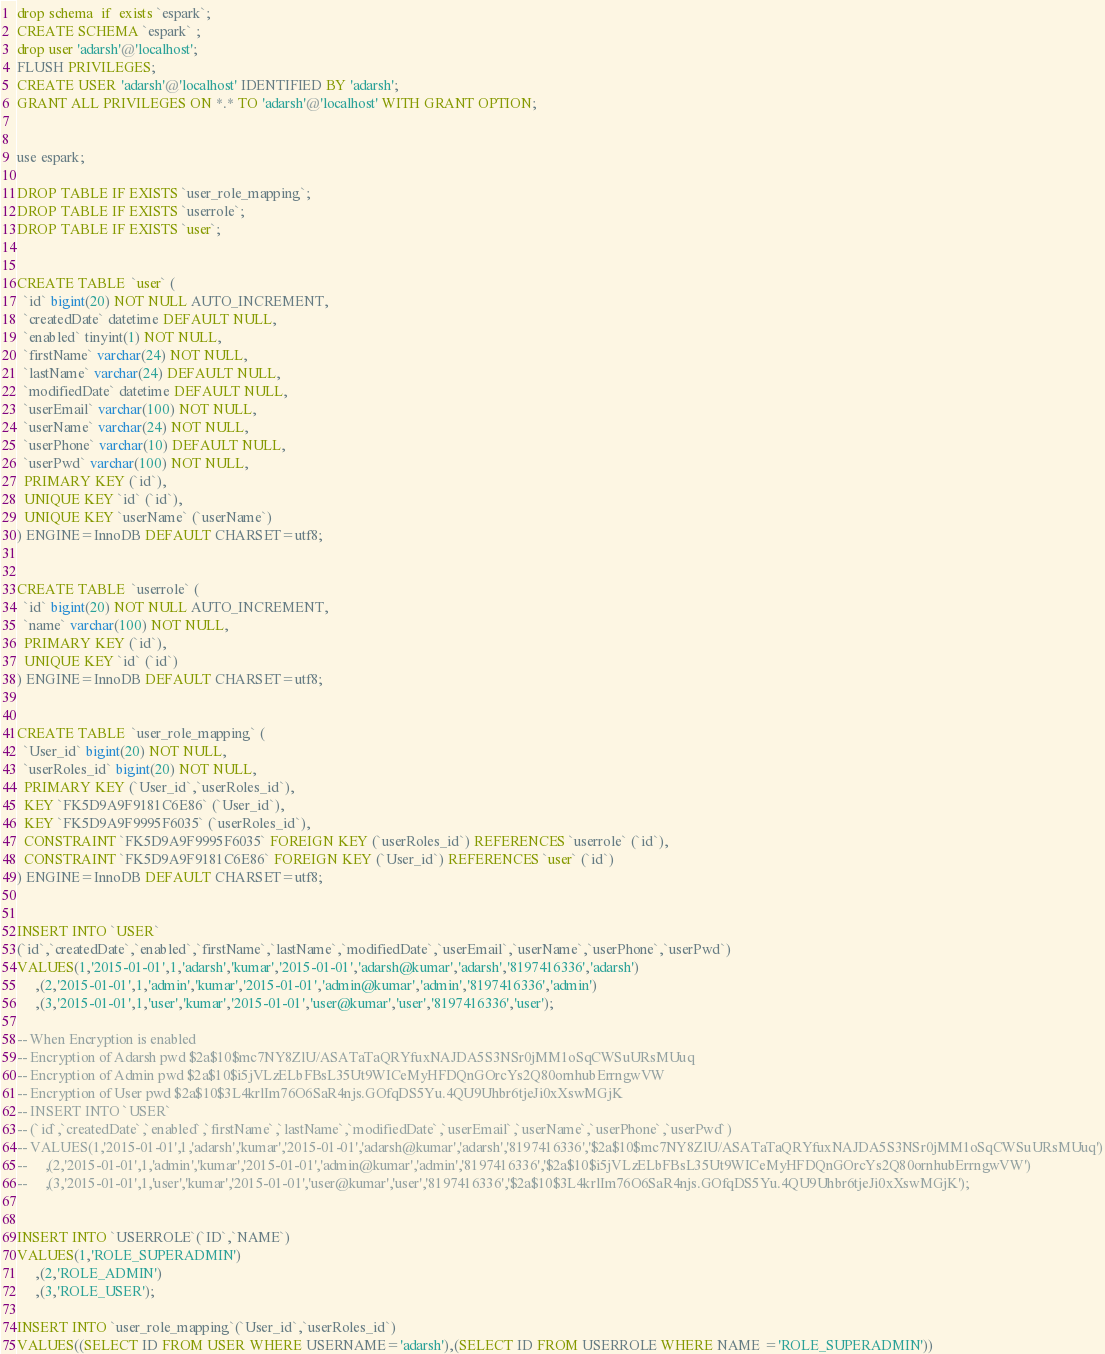Convert code to text. <code><loc_0><loc_0><loc_500><loc_500><_SQL_>drop schema  if  exists `espark`;
CREATE SCHEMA `espark` ;
drop user 'adarsh'@'localhost';
FLUSH PRIVILEGES;
CREATE USER 'adarsh'@'localhost' IDENTIFIED BY 'adarsh';
GRANT ALL PRIVILEGES ON *.* TO 'adarsh'@'localhost' WITH GRANT OPTION;


use espark;

DROP TABLE IF EXISTS `user_role_mapping`;
DROP TABLE IF EXISTS `userrole`;
DROP TABLE IF EXISTS `user`;


CREATE TABLE  `user` (
  `id` bigint(20) NOT NULL AUTO_INCREMENT,
  `createdDate` datetime DEFAULT NULL,
  `enabled` tinyint(1) NOT NULL,
  `firstName` varchar(24) NOT NULL,
  `lastName` varchar(24) DEFAULT NULL,
  `modifiedDate` datetime DEFAULT NULL,
  `userEmail` varchar(100) NOT NULL,
  `userName` varchar(24) NOT NULL,
  `userPhone` varchar(10) DEFAULT NULL,
  `userPwd` varchar(100) NOT NULL,
  PRIMARY KEY (`id`),
  UNIQUE KEY `id` (`id`),
  UNIQUE KEY `userName` (`userName`)
) ENGINE=InnoDB DEFAULT CHARSET=utf8;


CREATE TABLE  `userrole` (
  `id` bigint(20) NOT NULL AUTO_INCREMENT,
  `name` varchar(100) NOT NULL,
  PRIMARY KEY (`id`),
  UNIQUE KEY `id` (`id`)
) ENGINE=InnoDB DEFAULT CHARSET=utf8;


CREATE TABLE  `user_role_mapping` (
  `User_id` bigint(20) NOT NULL,
  `userRoles_id` bigint(20) NOT NULL,
  PRIMARY KEY (`User_id`,`userRoles_id`),
  KEY `FK5D9A9F9181C6E86` (`User_id`),
  KEY `FK5D9A9F9995F6035` (`userRoles_id`),
  CONSTRAINT `FK5D9A9F9995F6035` FOREIGN KEY (`userRoles_id`) REFERENCES `userrole` (`id`),
  CONSTRAINT `FK5D9A9F9181C6E86` FOREIGN KEY (`User_id`) REFERENCES `user` (`id`)
) ENGINE=InnoDB DEFAULT CHARSET=utf8;


INSERT INTO `USER`
(`id`,`createdDate`,`enabled`,`firstName`,`lastName`,`modifiedDate`,`userEmail`,`userName`,`userPhone`,`userPwd`)
VALUES(1,'2015-01-01',1,'adarsh','kumar','2015-01-01','adarsh@kumar','adarsh','8197416336','adarsh')
     ,(2,'2015-01-01',1,'admin','kumar','2015-01-01','admin@kumar','admin','8197416336','admin')
     ,(3,'2015-01-01',1,'user','kumar','2015-01-01','user@kumar','user','8197416336','user');

-- When Encryption is enabled
-- Encryption of Adarsh pwd $2a$10$mc7NY8ZlU/ASATaTaQRYfuxNAJDA5S3NSr0jMM1oSqCWSuURsMUuq
-- Encryption of Admin pwd $2a$10$i5jVLzELbFBsL35Ut9WICeMyHFDQnGOrcYs2Q80ornhubErrngwVW
-- Encryption of User pwd $2a$10$3L4krlIm76O6SaR4njs.GOfqDS5Yu.4QU9Uhbr6tjeJi0xXswMGjK
-- INSERT INTO `USER`
-- (`id`,`createdDate`,`enabled`,`firstName`,`lastName`,`modifiedDate`,`userEmail`,`userName`,`userPhone`,`userPwd`)
-- VALUES(1,'2015-01-01',1,'adarsh','kumar','2015-01-01','adarsh@kumar','adarsh','8197416336','$2a$10$mc7NY8ZlU/ASATaTaQRYfuxNAJDA5S3NSr0jMM1oSqCWSuURsMUuq')
--     ,(2,'2015-01-01',1,'admin','kumar','2015-01-01','admin@kumar','admin','8197416336','$2a$10$i5jVLzELbFBsL35Ut9WICeMyHFDQnGOrcYs2Q80ornhubErrngwVW')
--     ,(3,'2015-01-01',1,'user','kumar','2015-01-01','user@kumar','user','8197416336','$2a$10$3L4krlIm76O6SaR4njs.GOfqDS5Yu.4QU9Uhbr6tjeJi0xXswMGjK');


INSERT INTO `USERROLE`(`ID`,`NAME`)
VALUES(1,'ROLE_SUPERADMIN')
     ,(2,'ROLE_ADMIN')
     ,(3,'ROLE_USER');

INSERT INTO `user_role_mapping`(`User_id`,`userRoles_id`)
VALUES((SELECT ID FROM USER WHERE USERNAME='adarsh'),(SELECT ID FROM USERROLE WHERE NAME ='ROLE_SUPERADMIN'))</code> 